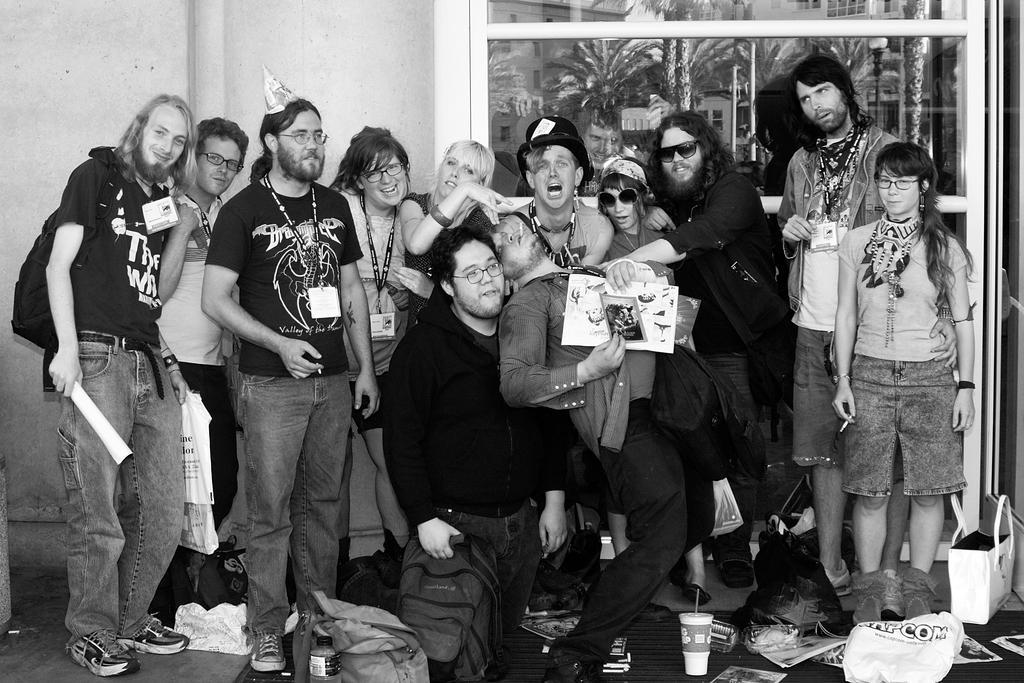How would you summarize this image in a sentence or two? This is an black and white image. In it we can see there are many people standing, wearing clothes, shoes and some of them are wearing spectacles, goggles and hat. Here we can see hand bag, plastic cover, glass, floor, wall and the window. 